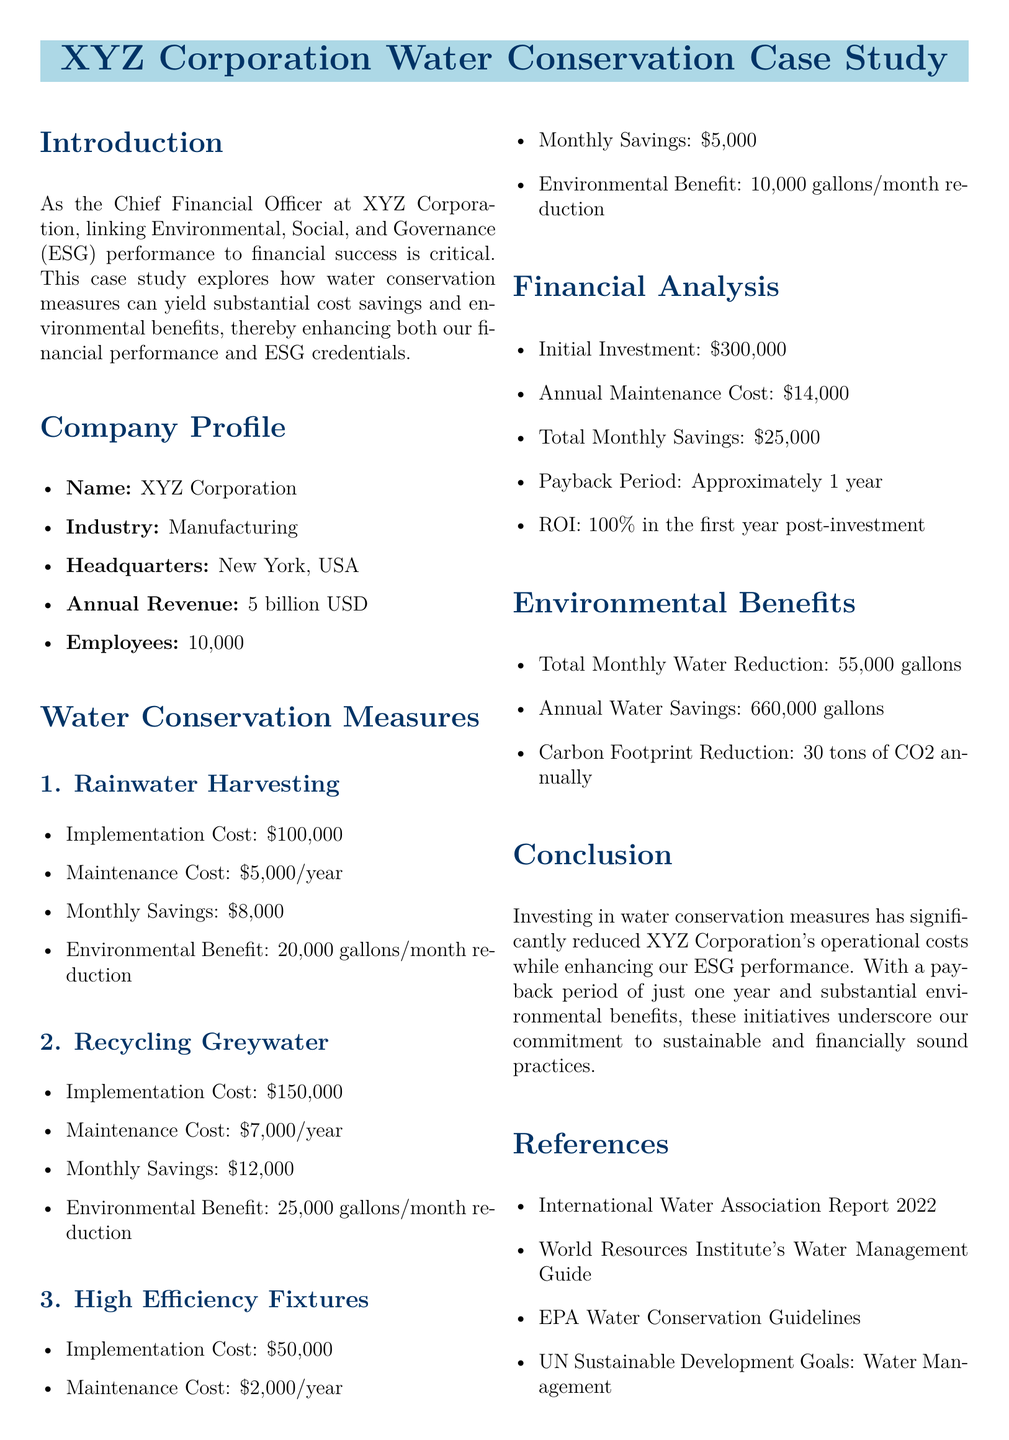What is the implementation cost of rainwater harvesting? The implementation cost of rainwater harvesting is mentioned in the water conservation measures section of the document.
Answer: $100,000 What are the monthly savings from recycling greywater? The monthly savings from recycling greywater are provided in the section detailing the water conservation measures.
Answer: $12,000 What is the annual water savings as a result of the conservation measures? The total annual water savings can be calculated from the monthly savings provided in the environmental benefits section.
Answer: 660,000 gallons What is the ROI in the first year post-investment? The ROI is explicitly stated in the financial analysis section of the document.
Answer: 100% How long is the payback period for the investments? The payback period is discussed in the financial analysis section of the case study.
Answer: Approximately 1 year What is the carbon footprint reduction annually? The document details the carbon footprint reduction in the environmental benefits section.
Answer: 30 tons of CO2 Which water conservation measure has the highest monthly savings? By comparing the monthly savings listed for each measure, we can determine which one is the highest.
Answer: Recycling Greywater What is the total implementation cost for all measures combined? The total implementation cost can be calculated by adding the costs of all individual measures detailed in the document.
Answer: $300,000 What is XYZ Corporation's annual revenue? The annual revenue is specified in the company profile section of the case study.
Answer: 5 billion USD 